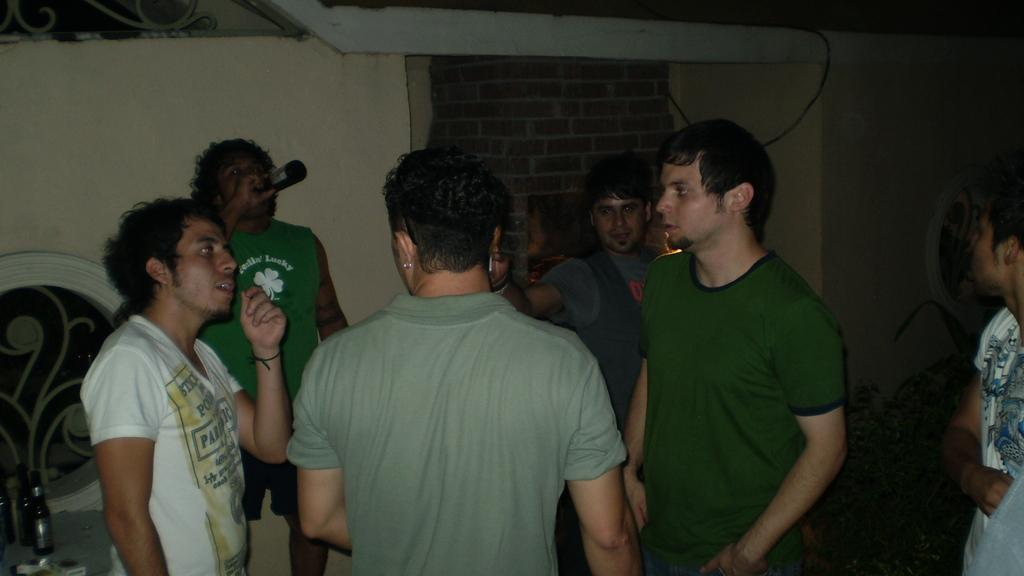What is happening in the image? There are people standing in the image. Can you describe what one person is holding? One person is holding a bottle. Are there any other bottles visible in the image? Yes, there are bottles visible in the image. What can be seen in the background of the image? There is a wall in the image. Where is the crib located in the image? There is no crib present in the image. What type of event is taking place in the image? The image does not depict a specific event; it simply shows people standing and holding bottles. 